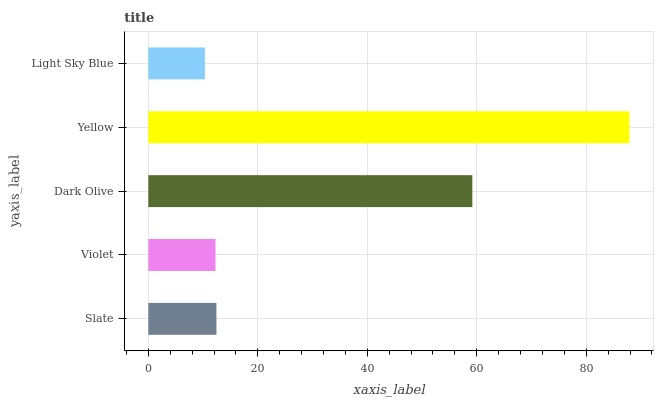Is Light Sky Blue the minimum?
Answer yes or no. Yes. Is Yellow the maximum?
Answer yes or no. Yes. Is Violet the minimum?
Answer yes or no. No. Is Violet the maximum?
Answer yes or no. No. Is Slate greater than Violet?
Answer yes or no. Yes. Is Violet less than Slate?
Answer yes or no. Yes. Is Violet greater than Slate?
Answer yes or no. No. Is Slate less than Violet?
Answer yes or no. No. Is Slate the high median?
Answer yes or no. Yes. Is Slate the low median?
Answer yes or no. Yes. Is Light Sky Blue the high median?
Answer yes or no. No. Is Dark Olive the low median?
Answer yes or no. No. 